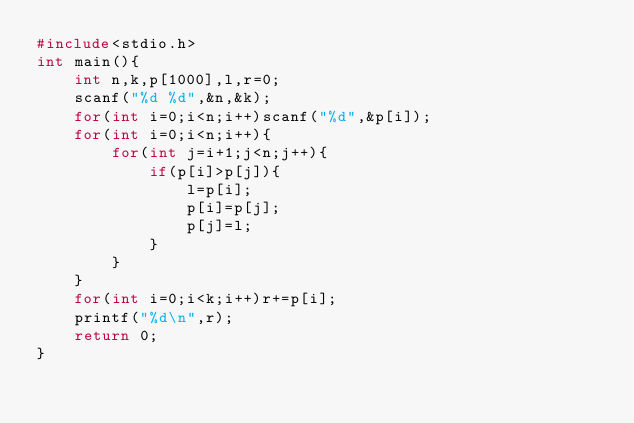Convert code to text. <code><loc_0><loc_0><loc_500><loc_500><_C_>#include<stdio.h>
int main(){
    int n,k,p[1000],l,r=0;
    scanf("%d %d",&n,&k);
    for(int i=0;i<n;i++)scanf("%d",&p[i]);
    for(int i=0;i<n;i++){
        for(int j=i+1;j<n;j++){
            if(p[i]>p[j]){
                l=p[i];
                p[i]=p[j];
                p[j]=l;
            }
        }
    }
    for(int i=0;i<k;i++)r+=p[i];
    printf("%d\n",r);
    return 0;
}</code> 